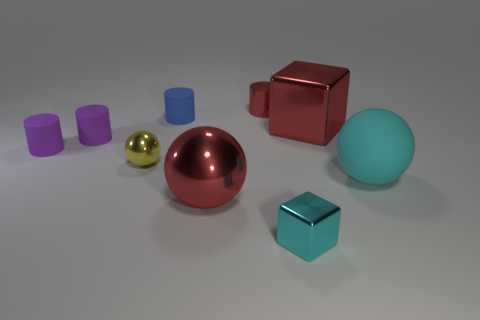There is a metal cube that is the same color as the big rubber ball; what size is it?
Your answer should be compact. Small. What number of other things are the same shape as the tiny cyan thing?
Offer a terse response. 1. Is the size of the cyan rubber ball the same as the yellow metallic object?
Ensure brevity in your answer.  No. Are there more tiny purple cylinders that are behind the blue cylinder than tiny cyan cubes behind the small cyan metallic block?
Ensure brevity in your answer.  No. How many other objects are the same size as the yellow thing?
Provide a succinct answer. 5. Do the tiny metal object in front of the small metallic sphere and the large shiny cube have the same color?
Provide a short and direct response. No. Are there more tiny yellow objects that are in front of the large cyan rubber object than large red shiny spheres?
Your answer should be very brief. No. Are there any other things that are the same color as the tiny metal cube?
Your answer should be very brief. Yes. There is a large object left of the small thing that is in front of the small yellow sphere; what shape is it?
Make the answer very short. Sphere. Is the number of tiny red cylinders greater than the number of large cyan metal balls?
Offer a very short reply. Yes. 